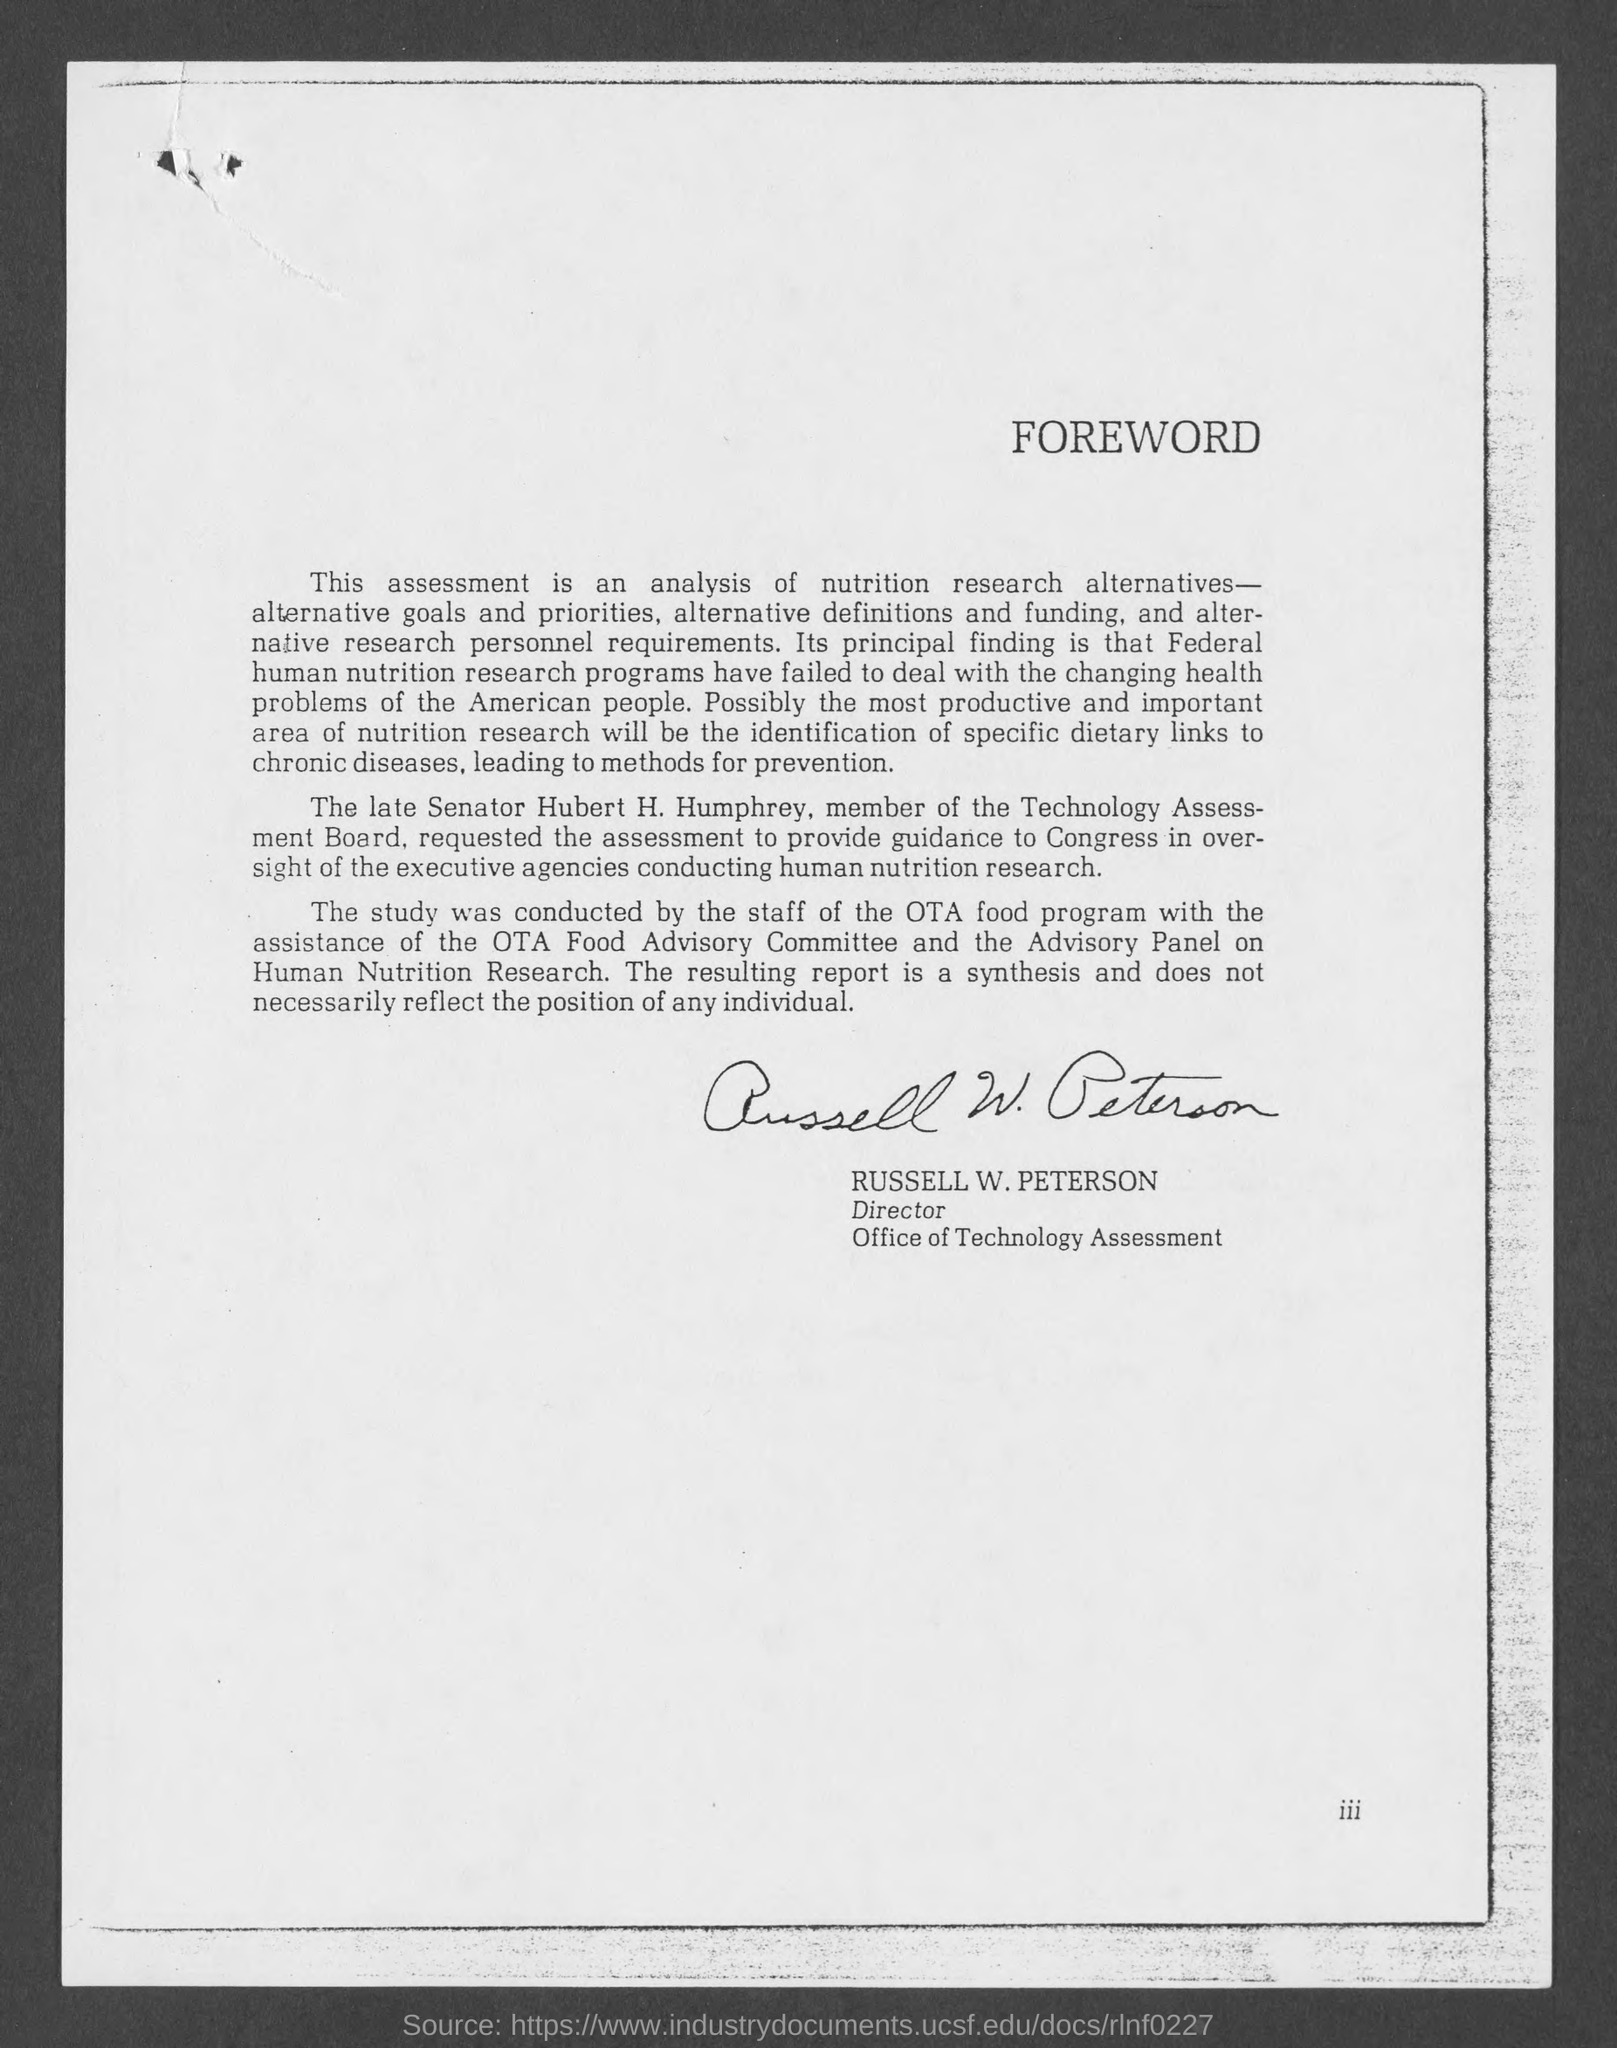Indicate a few pertinent items in this graphic. The signature on this document is that of Russell W. Peterson. 